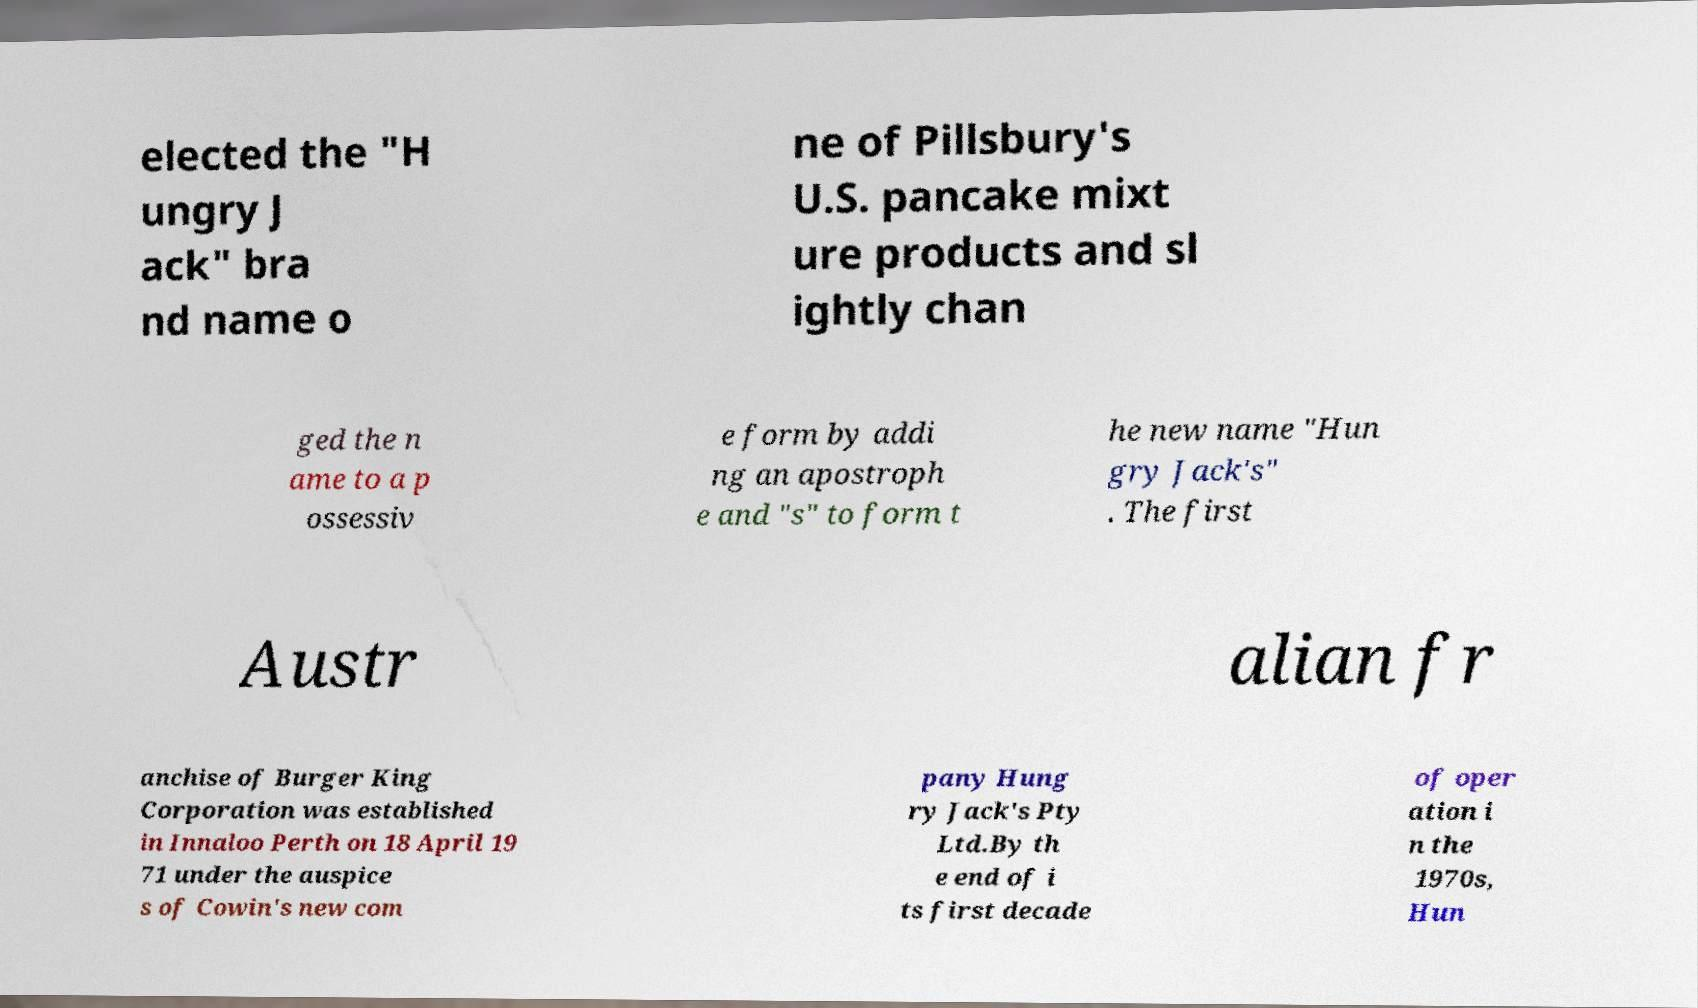Can you read and provide the text displayed in the image?This photo seems to have some interesting text. Can you extract and type it out for me? elected the "H ungry J ack" bra nd name o ne of Pillsbury's U.S. pancake mixt ure products and sl ightly chan ged the n ame to a p ossessiv e form by addi ng an apostroph e and "s" to form t he new name "Hun gry Jack's" . The first Austr alian fr anchise of Burger King Corporation was established in Innaloo Perth on 18 April 19 71 under the auspice s of Cowin's new com pany Hung ry Jack's Pty Ltd.By th e end of i ts first decade of oper ation i n the 1970s, Hun 